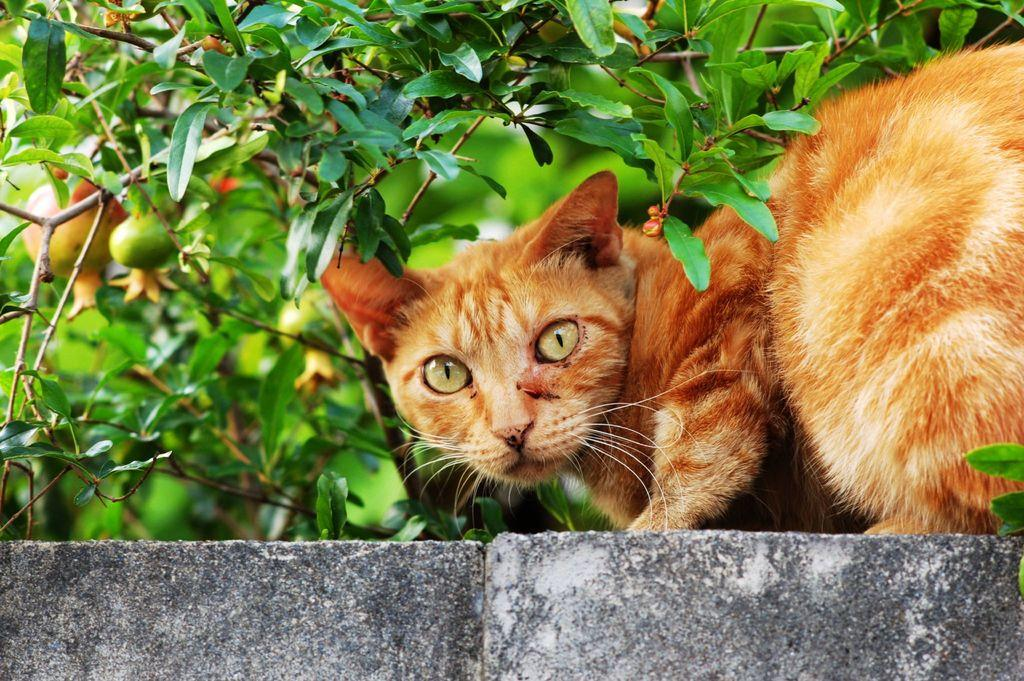What animal is present in the image? There is a cat in the image. What colors can be seen on the cat? The cat is green and brown in color. Where is the cat located in the image? The cat is on a wall. What color is the wall on which the cat is sitting? The wall is grey in color. What type of vegetation can be seen in the background of the image? There is a pomegranate tree in the background of the image. What type of record is being played in the image? There is no record present in the image; it features a cat on a wall with a pomegranate tree in the background. 